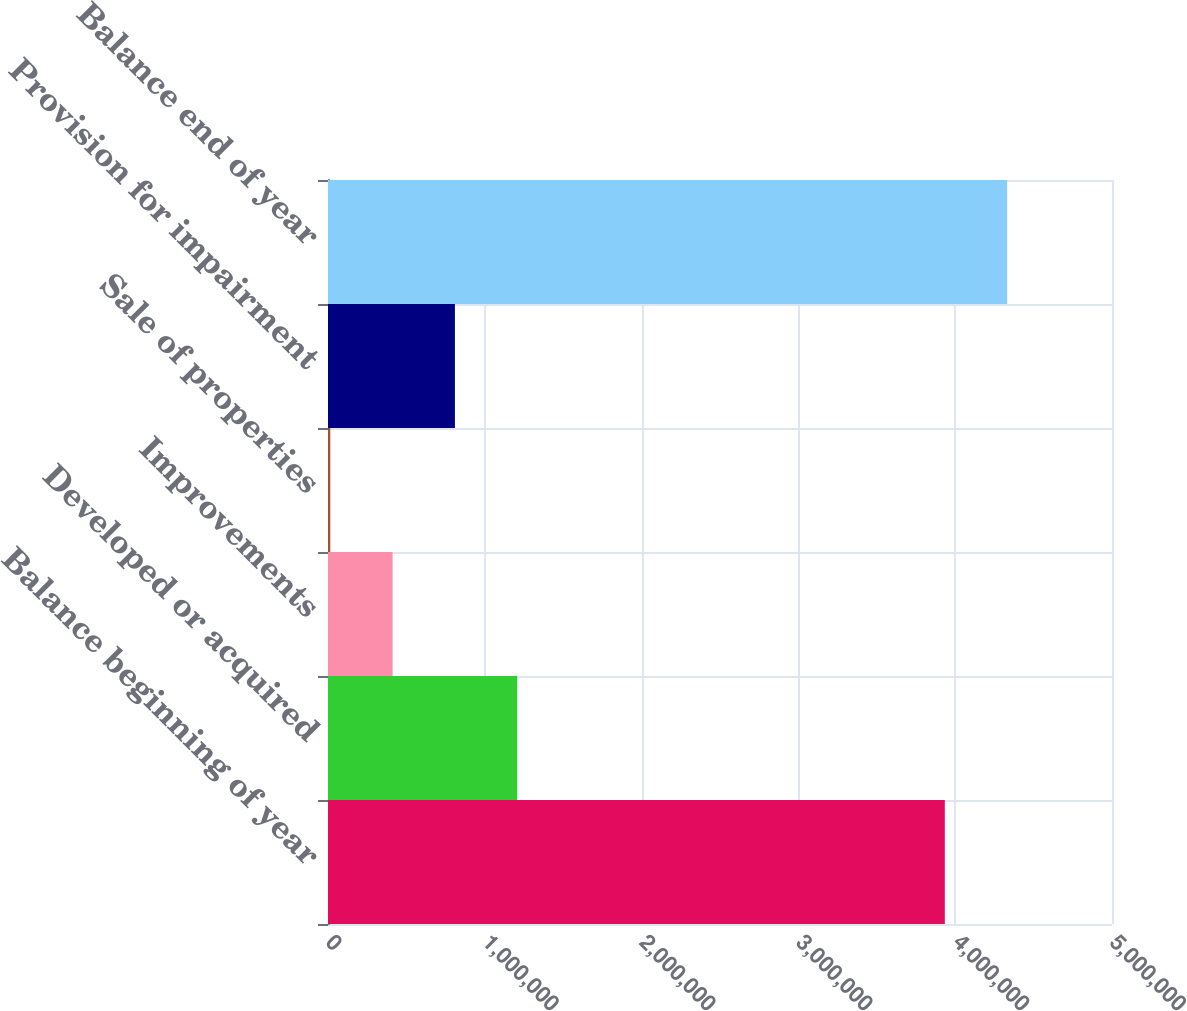<chart> <loc_0><loc_0><loc_500><loc_500><bar_chart><fcel>Balance beginning of year<fcel>Developed or acquired<fcel>Improvements<fcel>Sale of properties<fcel>Provision for impairment<fcel>Balance end of year<nl><fcel>3.93378e+06<fcel>1.2069e+06<fcel>411968<fcel>14503<fcel>809433<fcel>4.33124e+06<nl></chart> 